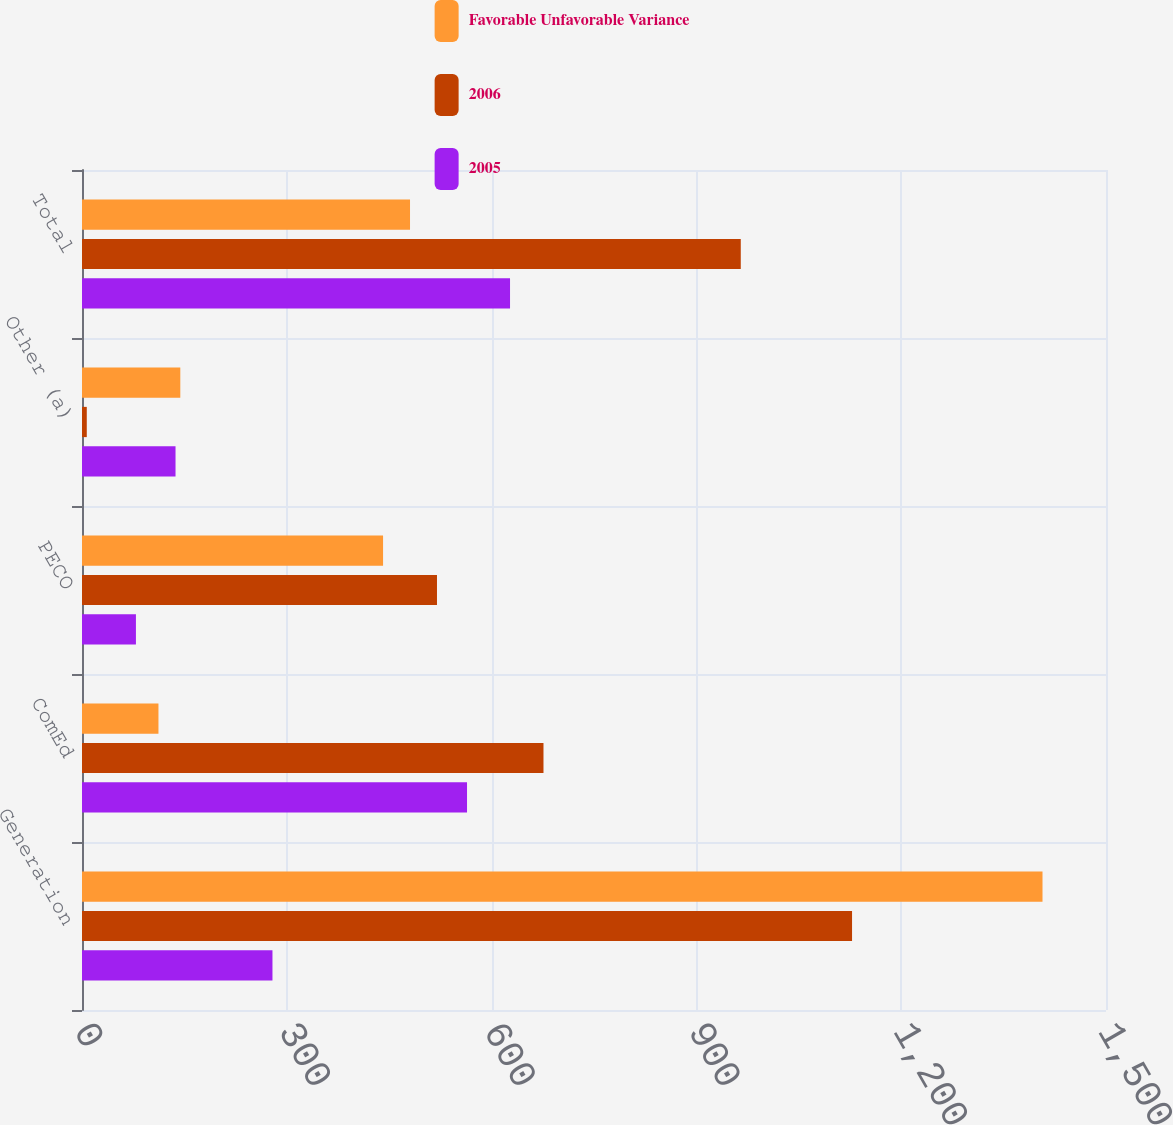Convert chart. <chart><loc_0><loc_0><loc_500><loc_500><stacked_bar_chart><ecel><fcel>Generation<fcel>ComEd<fcel>PECO<fcel>Other (a)<fcel>Total<nl><fcel>Favorable Unfavorable Variance<fcel>1407<fcel>112<fcel>441<fcel>144<fcel>480.5<nl><fcel>2006<fcel>1128<fcel>676<fcel>520<fcel>7<fcel>965<nl><fcel>2005<fcel>279<fcel>564<fcel>79<fcel>137<fcel>627<nl></chart> 